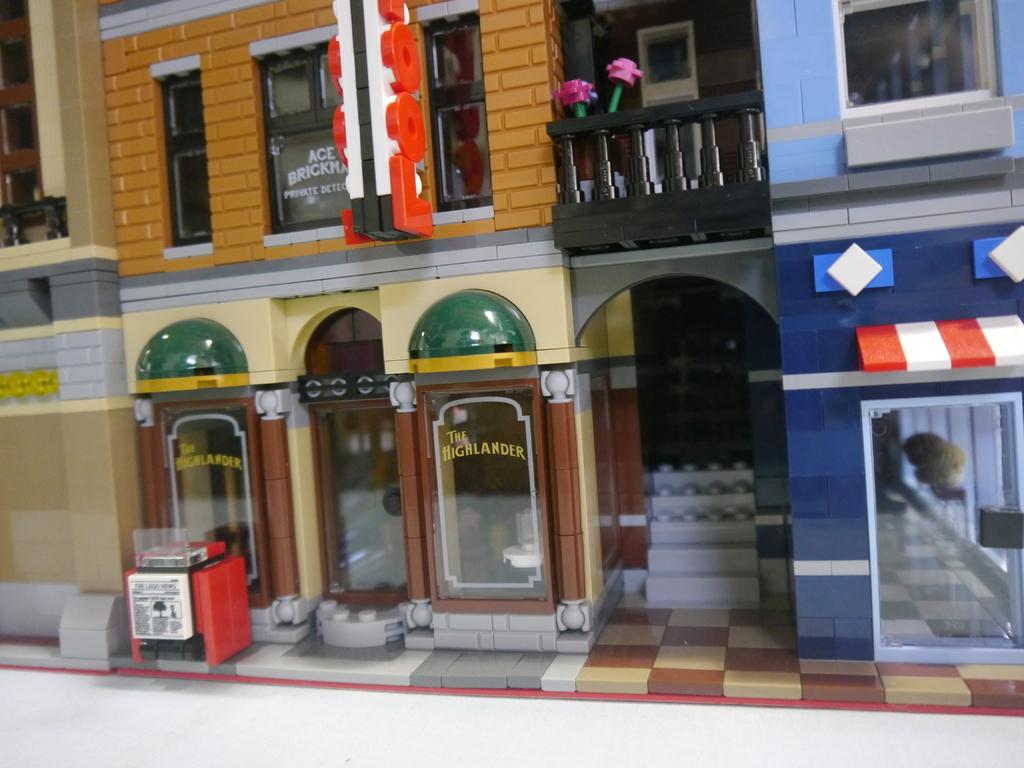<image>
Share a concise interpretation of the image provided. A lego city with a small cafe called The Highlander sits below two pink lego flowers 